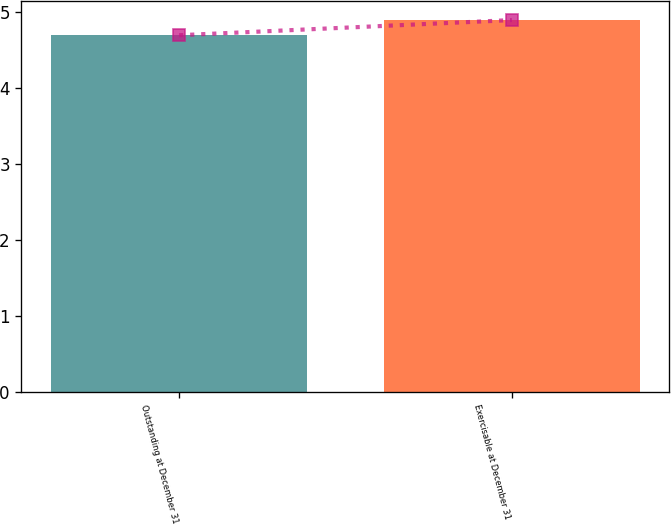Convert chart. <chart><loc_0><loc_0><loc_500><loc_500><bar_chart><fcel>Outstanding at December 31<fcel>Exercisable at December 31<nl><fcel>4.7<fcel>4.9<nl></chart> 